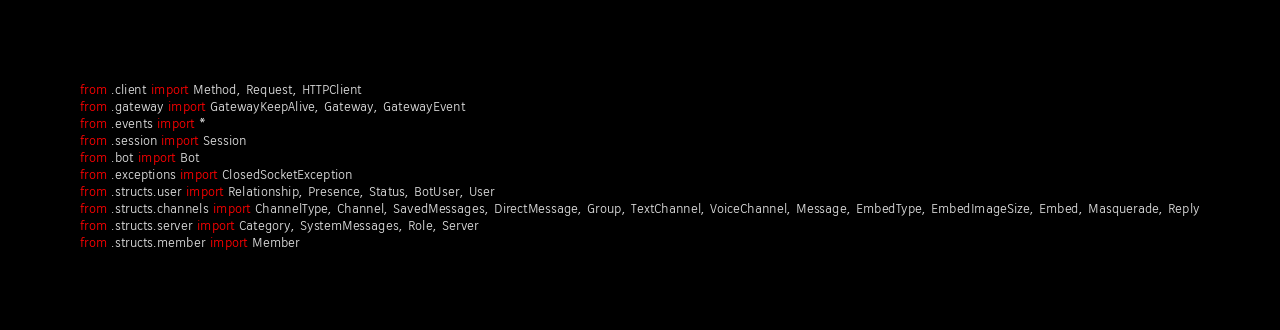<code> <loc_0><loc_0><loc_500><loc_500><_Python_>from .client import Method, Request, HTTPClient
from .gateway import GatewayKeepAlive, Gateway, GatewayEvent
from .events import *
from .session import Session
from .bot import Bot
from .exceptions import ClosedSocketException
from .structs.user import Relationship, Presence, Status, BotUser, User
from .structs.channels import ChannelType, Channel, SavedMessages, DirectMessage, Group, TextChannel, VoiceChannel, Message, EmbedType, EmbedImageSize, Embed, Masquerade, Reply
from .structs.server import Category, SystemMessages, Role, Server
from .structs.member import Member</code> 